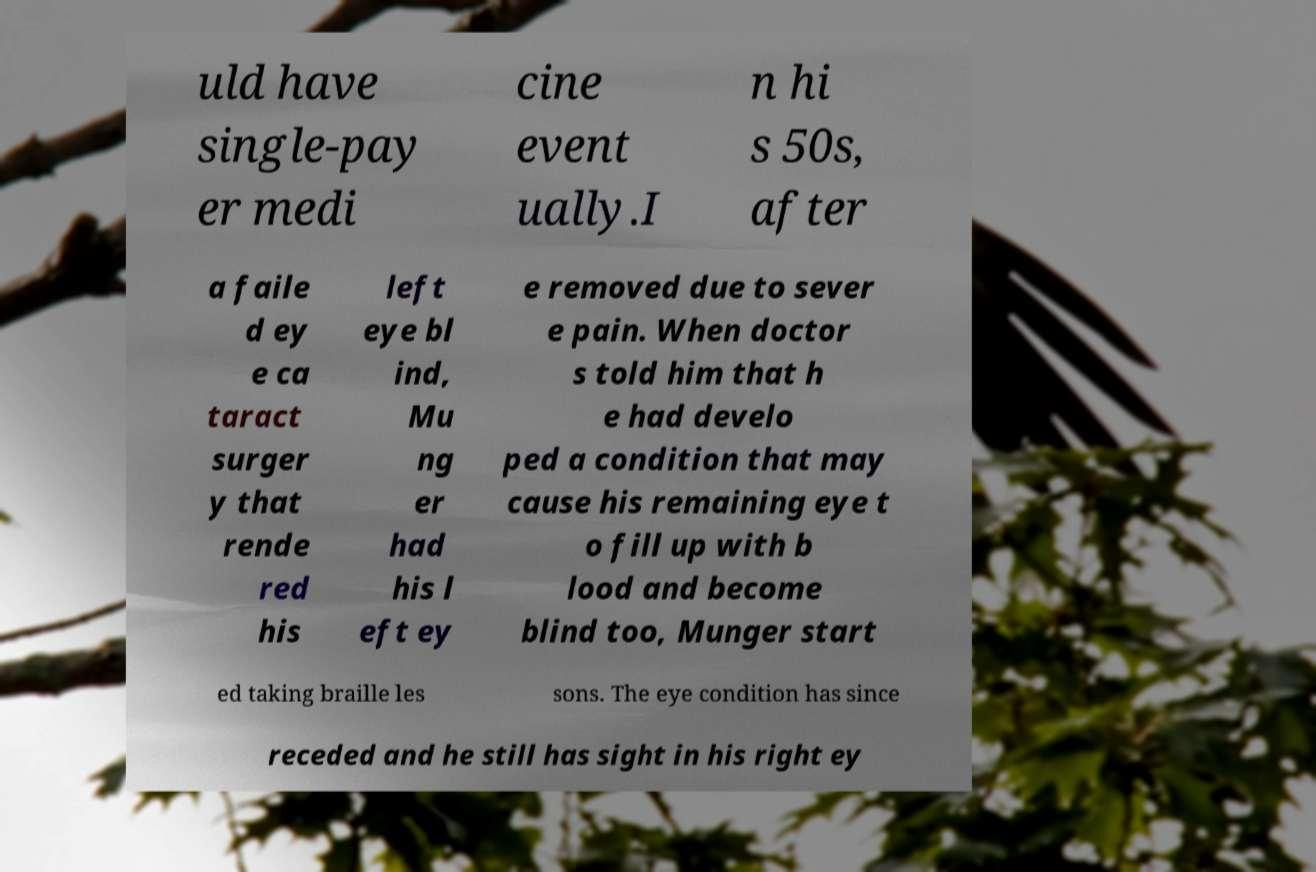Please identify and transcribe the text found in this image. uld have single-pay er medi cine event ually.I n hi s 50s, after a faile d ey e ca taract surger y that rende red his left eye bl ind, Mu ng er had his l eft ey e removed due to sever e pain. When doctor s told him that h e had develo ped a condition that may cause his remaining eye t o fill up with b lood and become blind too, Munger start ed taking braille les sons. The eye condition has since receded and he still has sight in his right ey 